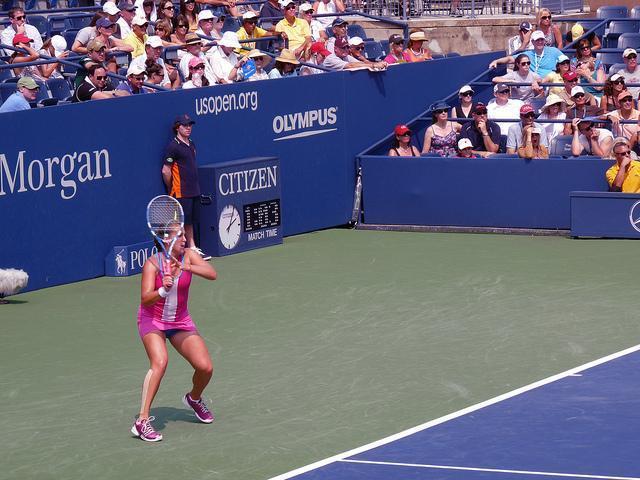How many people are visible?
Give a very brief answer. 2. 